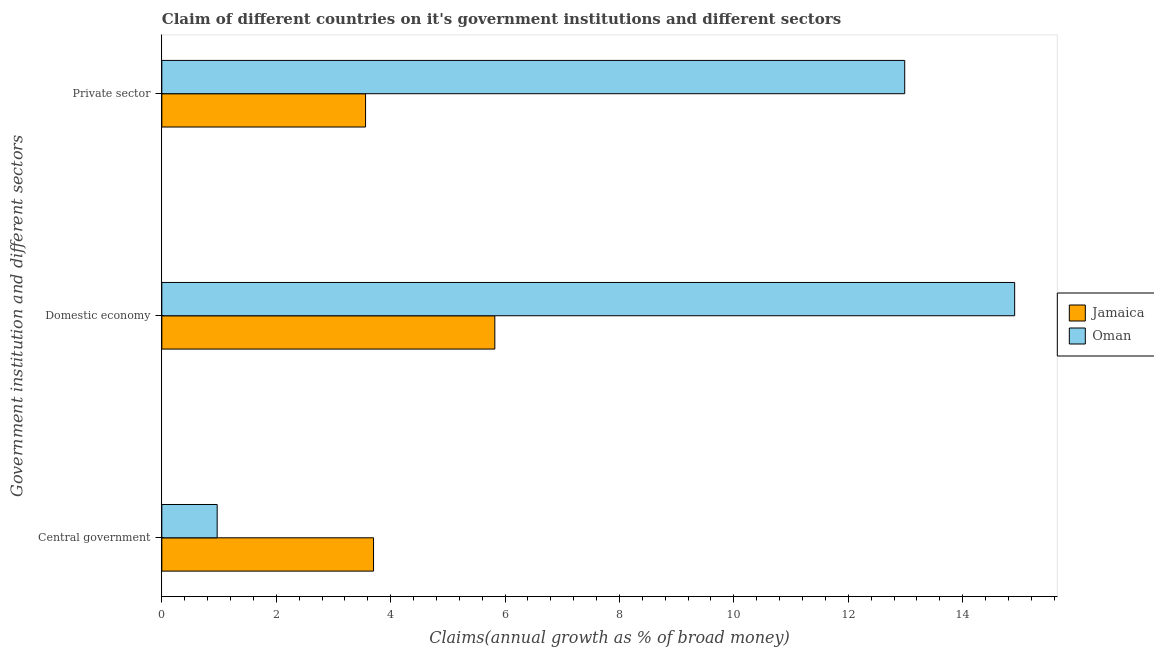How many groups of bars are there?
Ensure brevity in your answer.  3. Are the number of bars per tick equal to the number of legend labels?
Your response must be concise. Yes. Are the number of bars on each tick of the Y-axis equal?
Provide a short and direct response. Yes. What is the label of the 2nd group of bars from the top?
Your answer should be very brief. Domestic economy. What is the percentage of claim on the private sector in Jamaica?
Ensure brevity in your answer.  3.56. Across all countries, what is the maximum percentage of claim on the central government?
Your answer should be very brief. 3.7. Across all countries, what is the minimum percentage of claim on the private sector?
Provide a succinct answer. 3.56. In which country was the percentage of claim on the central government maximum?
Make the answer very short. Jamaica. In which country was the percentage of claim on the central government minimum?
Your answer should be very brief. Oman. What is the total percentage of claim on the private sector in the graph?
Keep it short and to the point. 16.55. What is the difference between the percentage of claim on the private sector in Jamaica and that in Oman?
Give a very brief answer. -9.43. What is the difference between the percentage of claim on the central government in Jamaica and the percentage of claim on the domestic economy in Oman?
Make the answer very short. -11.21. What is the average percentage of claim on the central government per country?
Make the answer very short. 2.33. What is the difference between the percentage of claim on the private sector and percentage of claim on the central government in Oman?
Offer a terse response. 12.02. What is the ratio of the percentage of claim on the central government in Jamaica to that in Oman?
Keep it short and to the point. 3.83. Is the percentage of claim on the private sector in Oman less than that in Jamaica?
Offer a very short reply. No. Is the difference between the percentage of claim on the private sector in Oman and Jamaica greater than the difference between the percentage of claim on the central government in Oman and Jamaica?
Your answer should be compact. Yes. What is the difference between the highest and the second highest percentage of claim on the central government?
Ensure brevity in your answer.  2.73. What is the difference between the highest and the lowest percentage of claim on the central government?
Your answer should be very brief. 2.73. Is the sum of the percentage of claim on the domestic economy in Oman and Jamaica greater than the maximum percentage of claim on the private sector across all countries?
Your answer should be very brief. Yes. What does the 2nd bar from the top in Central government represents?
Keep it short and to the point. Jamaica. What does the 2nd bar from the bottom in Domestic economy represents?
Offer a terse response. Oman. Is it the case that in every country, the sum of the percentage of claim on the central government and percentage of claim on the domestic economy is greater than the percentage of claim on the private sector?
Your answer should be compact. Yes. How many bars are there?
Your response must be concise. 6. Does the graph contain any zero values?
Offer a terse response. No. Does the graph contain grids?
Provide a succinct answer. No. What is the title of the graph?
Ensure brevity in your answer.  Claim of different countries on it's government institutions and different sectors. What is the label or title of the X-axis?
Offer a very short reply. Claims(annual growth as % of broad money). What is the label or title of the Y-axis?
Your answer should be very brief. Government institution and different sectors. What is the Claims(annual growth as % of broad money) of Jamaica in Central government?
Offer a very short reply. 3.7. What is the Claims(annual growth as % of broad money) in Oman in Central government?
Your answer should be compact. 0.97. What is the Claims(annual growth as % of broad money) of Jamaica in Domestic economy?
Offer a terse response. 5.82. What is the Claims(annual growth as % of broad money) in Oman in Domestic economy?
Give a very brief answer. 14.91. What is the Claims(annual growth as % of broad money) of Jamaica in Private sector?
Provide a short and direct response. 3.56. What is the Claims(annual growth as % of broad money) of Oman in Private sector?
Your answer should be very brief. 12.99. Across all Government institution and different sectors, what is the maximum Claims(annual growth as % of broad money) of Jamaica?
Your answer should be compact. 5.82. Across all Government institution and different sectors, what is the maximum Claims(annual growth as % of broad money) of Oman?
Keep it short and to the point. 14.91. Across all Government institution and different sectors, what is the minimum Claims(annual growth as % of broad money) of Jamaica?
Ensure brevity in your answer.  3.56. Across all Government institution and different sectors, what is the minimum Claims(annual growth as % of broad money) in Oman?
Provide a short and direct response. 0.97. What is the total Claims(annual growth as % of broad money) of Jamaica in the graph?
Provide a succinct answer. 13.08. What is the total Claims(annual growth as % of broad money) in Oman in the graph?
Your answer should be very brief. 28.86. What is the difference between the Claims(annual growth as % of broad money) in Jamaica in Central government and that in Domestic economy?
Provide a succinct answer. -2.12. What is the difference between the Claims(annual growth as % of broad money) of Oman in Central government and that in Domestic economy?
Make the answer very short. -13.94. What is the difference between the Claims(annual growth as % of broad money) in Jamaica in Central government and that in Private sector?
Offer a terse response. 0.14. What is the difference between the Claims(annual growth as % of broad money) in Oman in Central government and that in Private sector?
Offer a terse response. -12.02. What is the difference between the Claims(annual growth as % of broad money) in Jamaica in Domestic economy and that in Private sector?
Ensure brevity in your answer.  2.26. What is the difference between the Claims(annual growth as % of broad money) of Oman in Domestic economy and that in Private sector?
Offer a terse response. 1.92. What is the difference between the Claims(annual growth as % of broad money) in Jamaica in Central government and the Claims(annual growth as % of broad money) in Oman in Domestic economy?
Offer a very short reply. -11.21. What is the difference between the Claims(annual growth as % of broad money) of Jamaica in Central government and the Claims(annual growth as % of broad money) of Oman in Private sector?
Provide a short and direct response. -9.29. What is the difference between the Claims(annual growth as % of broad money) in Jamaica in Domestic economy and the Claims(annual growth as % of broad money) in Oman in Private sector?
Offer a very short reply. -7.17. What is the average Claims(annual growth as % of broad money) of Jamaica per Government institution and different sectors?
Make the answer very short. 4.36. What is the average Claims(annual growth as % of broad money) in Oman per Government institution and different sectors?
Provide a short and direct response. 9.62. What is the difference between the Claims(annual growth as % of broad money) of Jamaica and Claims(annual growth as % of broad money) of Oman in Central government?
Your answer should be compact. 2.73. What is the difference between the Claims(annual growth as % of broad money) in Jamaica and Claims(annual growth as % of broad money) in Oman in Domestic economy?
Your answer should be very brief. -9.09. What is the difference between the Claims(annual growth as % of broad money) of Jamaica and Claims(annual growth as % of broad money) of Oman in Private sector?
Your answer should be very brief. -9.43. What is the ratio of the Claims(annual growth as % of broad money) of Jamaica in Central government to that in Domestic economy?
Offer a very short reply. 0.64. What is the ratio of the Claims(annual growth as % of broad money) of Oman in Central government to that in Domestic economy?
Your answer should be very brief. 0.06. What is the ratio of the Claims(annual growth as % of broad money) of Jamaica in Central government to that in Private sector?
Provide a short and direct response. 1.04. What is the ratio of the Claims(annual growth as % of broad money) in Oman in Central government to that in Private sector?
Give a very brief answer. 0.07. What is the ratio of the Claims(annual growth as % of broad money) of Jamaica in Domestic economy to that in Private sector?
Your response must be concise. 1.63. What is the ratio of the Claims(annual growth as % of broad money) in Oman in Domestic economy to that in Private sector?
Make the answer very short. 1.15. What is the difference between the highest and the second highest Claims(annual growth as % of broad money) of Jamaica?
Provide a short and direct response. 2.12. What is the difference between the highest and the second highest Claims(annual growth as % of broad money) of Oman?
Keep it short and to the point. 1.92. What is the difference between the highest and the lowest Claims(annual growth as % of broad money) of Jamaica?
Provide a short and direct response. 2.26. What is the difference between the highest and the lowest Claims(annual growth as % of broad money) in Oman?
Keep it short and to the point. 13.94. 